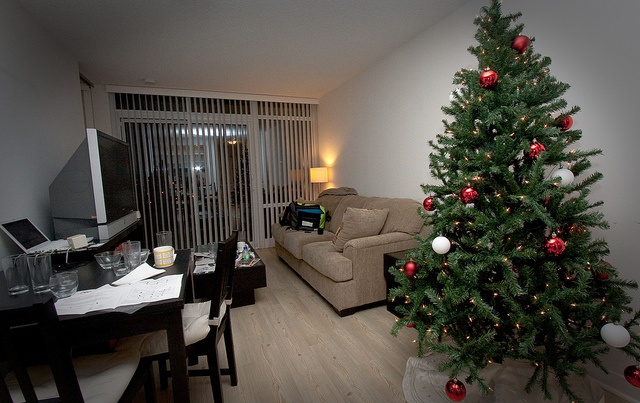Describe the objects in this image and their specific colors. I can see couch in black, gray, and maroon tones, dining table in black and gray tones, tv in black, gray, darkgray, and purple tones, chair in black, gray, and darkgray tones, and chair in black, gray, and darkgray tones in this image. 